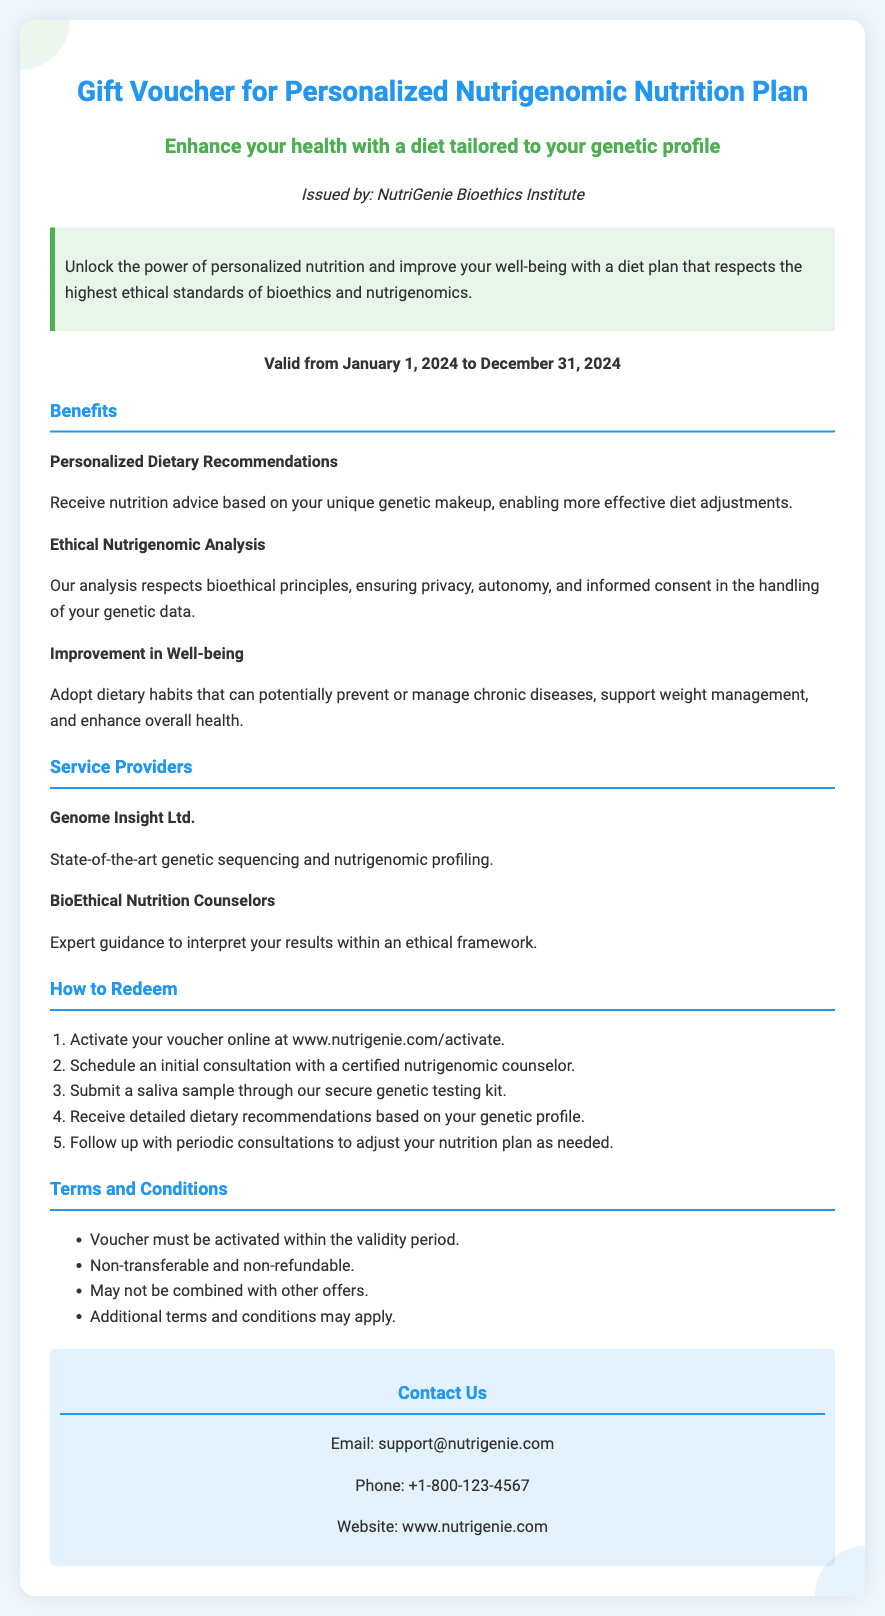What is the validity period of the voucher? The validity period of the voucher is specified in the document as running from January 1, 2024, to December 31, 2024.
Answer: January 1, 2024 to December 31, 2024 Who issued the gift voucher? The issuer of the gift voucher is mentioned in the document, which is the NutriGenie Bioethics Institute.
Answer: NutriGenie Bioethics Institute What is one of the benefits of the personalized nutrition plan? The document lists multiple benefits, one of which includes receiving nutrition advice based on your unique genetic makeup.
Answer: Personalized Dietary Recommendations What must be done first to redeem the voucher? The first step to redeem the voucher is activating it online at the specified website.
Answer: Activate your voucher online at www.nutrigenie.com/activate Name one of the service providers listed in the document. The document includes names of service providers, one of which is Genome Insight Ltd.
Answer: Genome Insight Ltd How many steps are in the redemption process? The number of steps required to redeem the voucher is given in an ordered list in the document.
Answer: Five steps What is a key ethical principle respected in the analysis? The document highlights that the ethical nutrigenomic analysis respects privacy, autonomy, and informed consent.
Answer: Informed consent Is the voucher transferable? The document outlines the terms and conditions regarding the voucher’s transferability.
Answer: Non-transferable What type of consultation is scheduled after activating the voucher? The document specifies that an initial consultation is scheduled with a certified nutrigenomic counselor.
Answer: Certified nutrigenomic counselor 